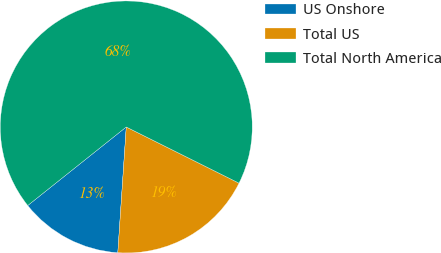Convert chart to OTSL. <chart><loc_0><loc_0><loc_500><loc_500><pie_chart><fcel>US Onshore<fcel>Total US<fcel>Total North America<nl><fcel>13.22%<fcel>18.71%<fcel>68.07%<nl></chart> 